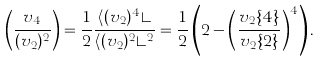<formula> <loc_0><loc_0><loc_500><loc_500>\left ( \frac { v _ { 4 } } { ( v _ { 2 } ) ^ { 2 } } \right ) = \frac { 1 } { 2 } \frac { \langle ( v _ { 2 } ) ^ { 4 } \rangle } { \langle ( v _ { 2 } ) ^ { 2 } \rangle ^ { 2 } } = \frac { 1 } { 2 } \left ( 2 - \left ( \frac { v _ { 2 } \{ 4 \} } { v _ { 2 } \{ 2 \} } \right ) ^ { 4 } \right ) .</formula> 